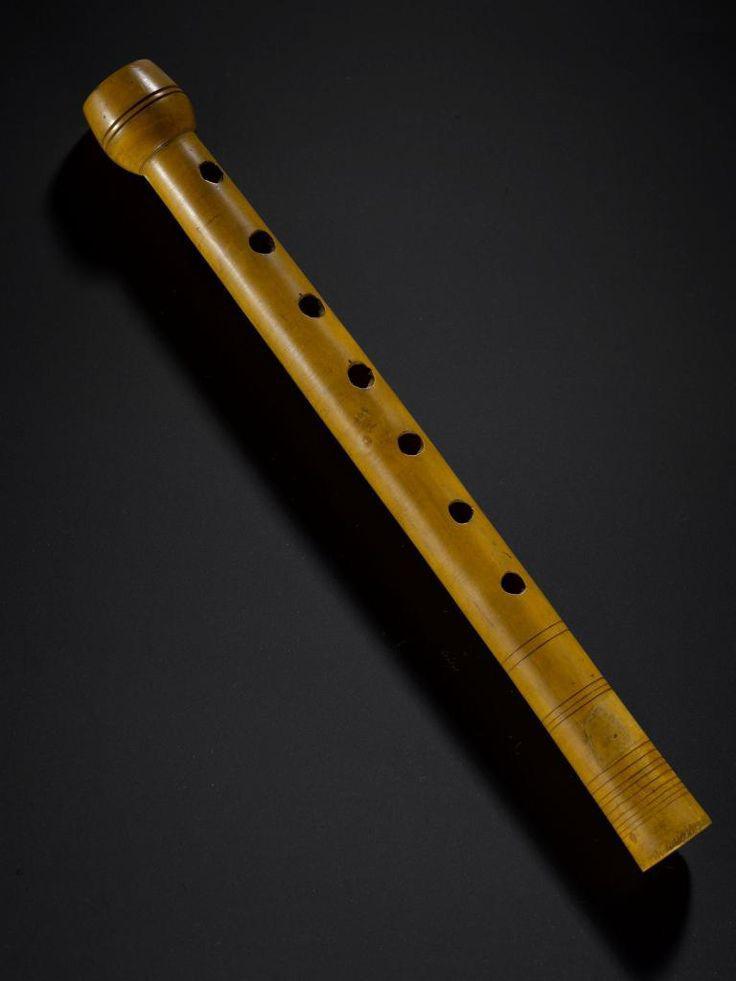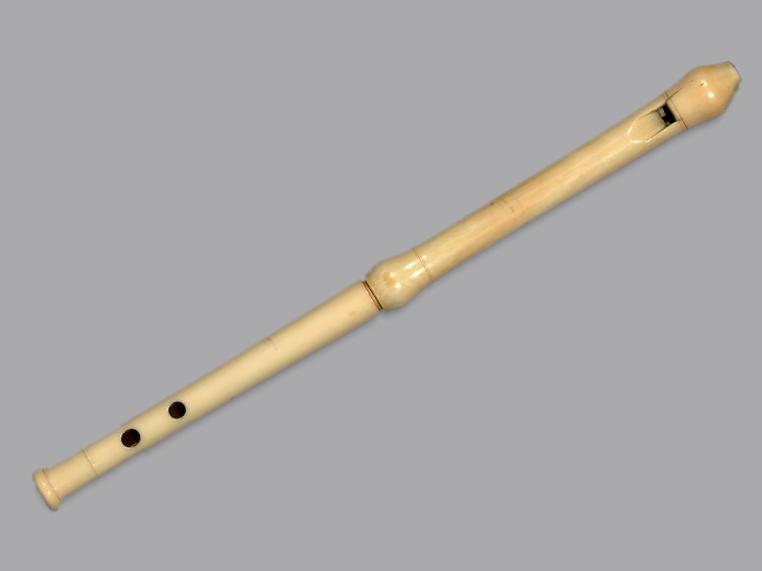The first image is the image on the left, the second image is the image on the right. Assess this claim about the two images: "The left and right image contains a total of two flutes.". Correct or not? Answer yes or no. Yes. 